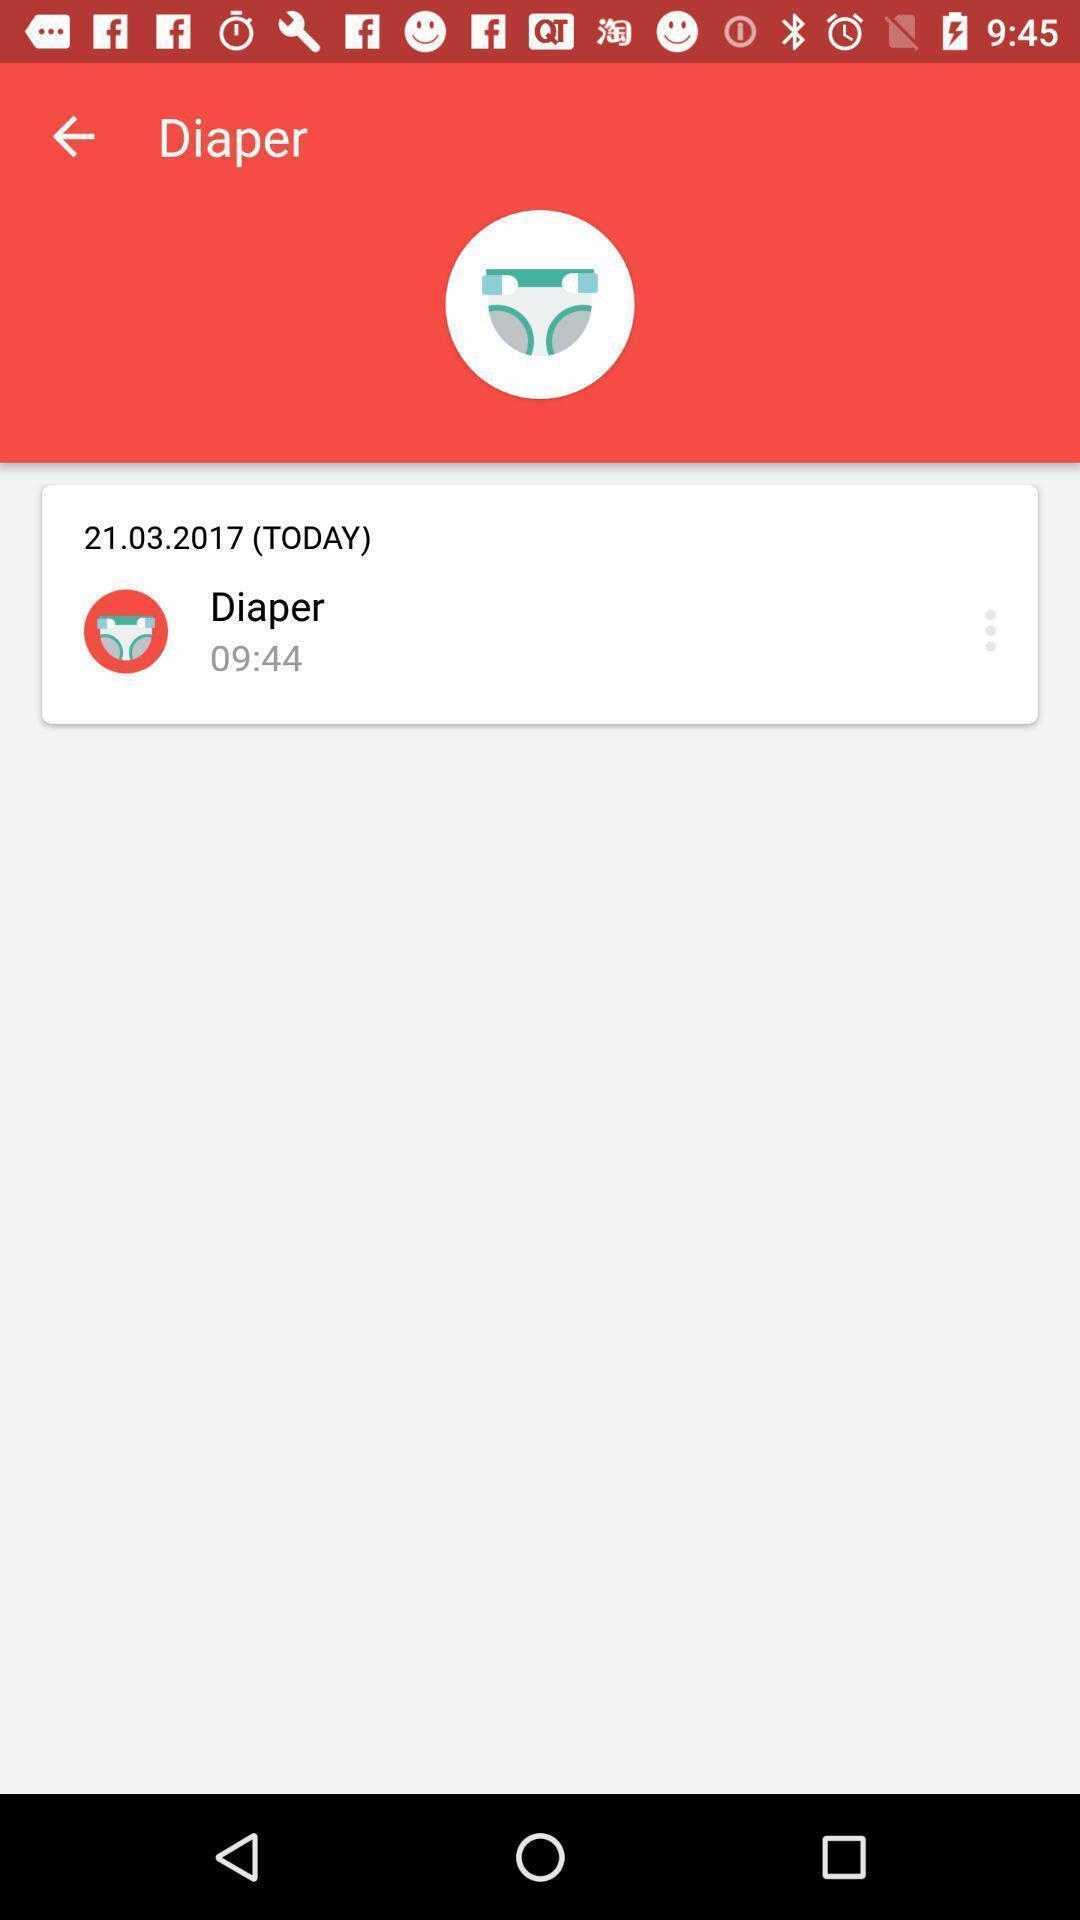Provide a description of this screenshot. Page shows the date and time details of diaper. 